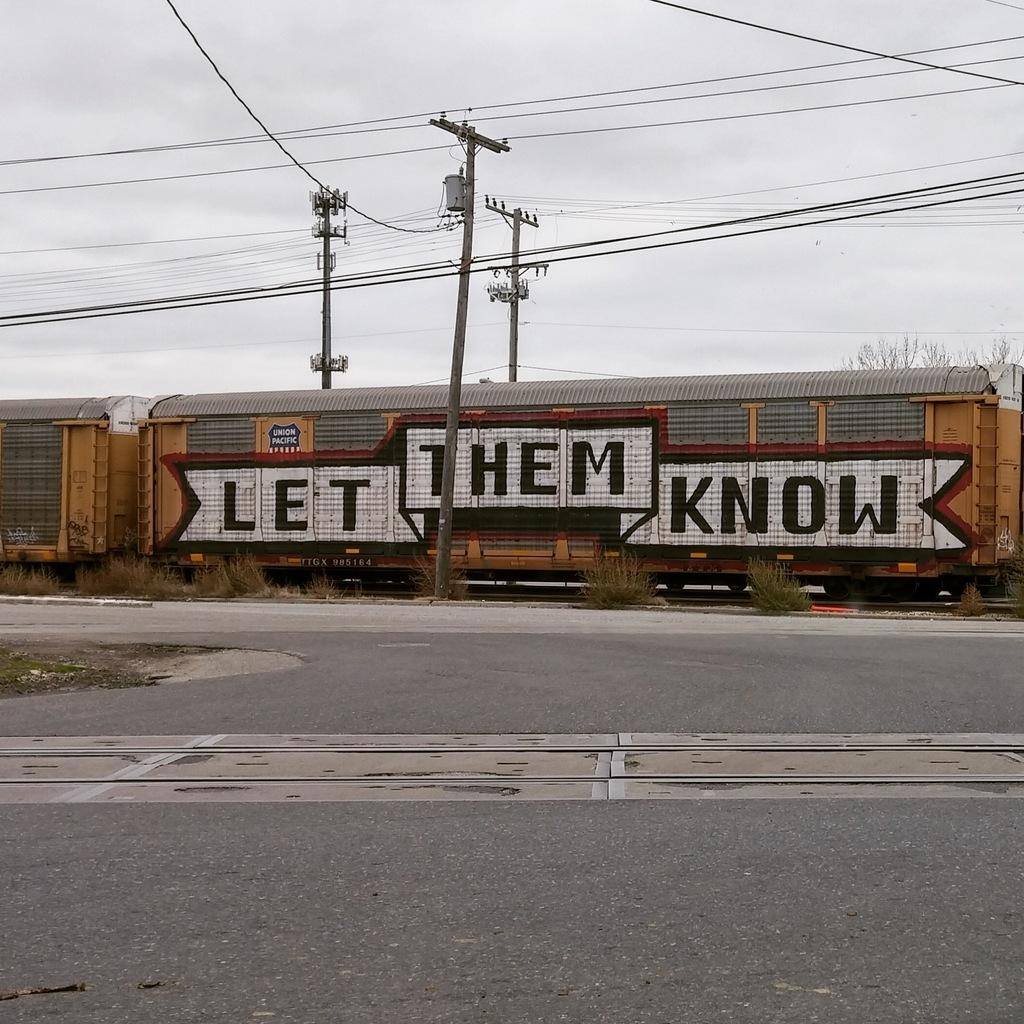What is the main feature of the image? There is a road in the image. What mode of transportation can be seen in the image? There is a train in the image. What type of vegetation is present in the image? There are plants in the image. What structures can be seen in the image? There are poles in the image. What is connected to the poles in the image? There are wires in the image. Can you describe the background of the image? The sky is visible in the background of the image. What type of garden can be seen in the image? There is no garden present in the image. What fact is being presented in the image? The image itself is not presenting a fact; it is a visual representation of various elements. 